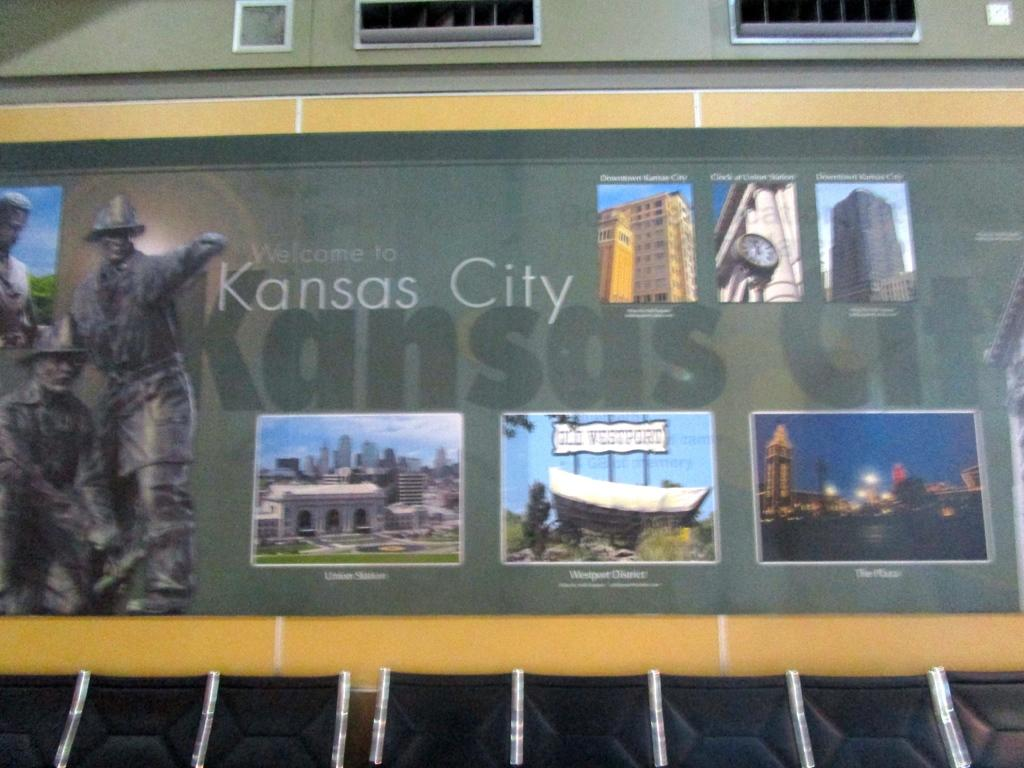Provide a one-sentence caption for the provided image. A display on a building commemorating Kansas City's locations. 